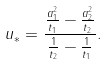Convert formula to latex. <formula><loc_0><loc_0><loc_500><loc_500>u _ { * } = \frac { \frac { a _ { 1 } ^ { 2 } } { t _ { 1 } } - \frac { a _ { 2 } ^ { 2 } } { t _ { 2 } } } { \frac { 1 } { t _ { 2 } } - \frac { 1 } { t _ { 1 } } } .</formula> 